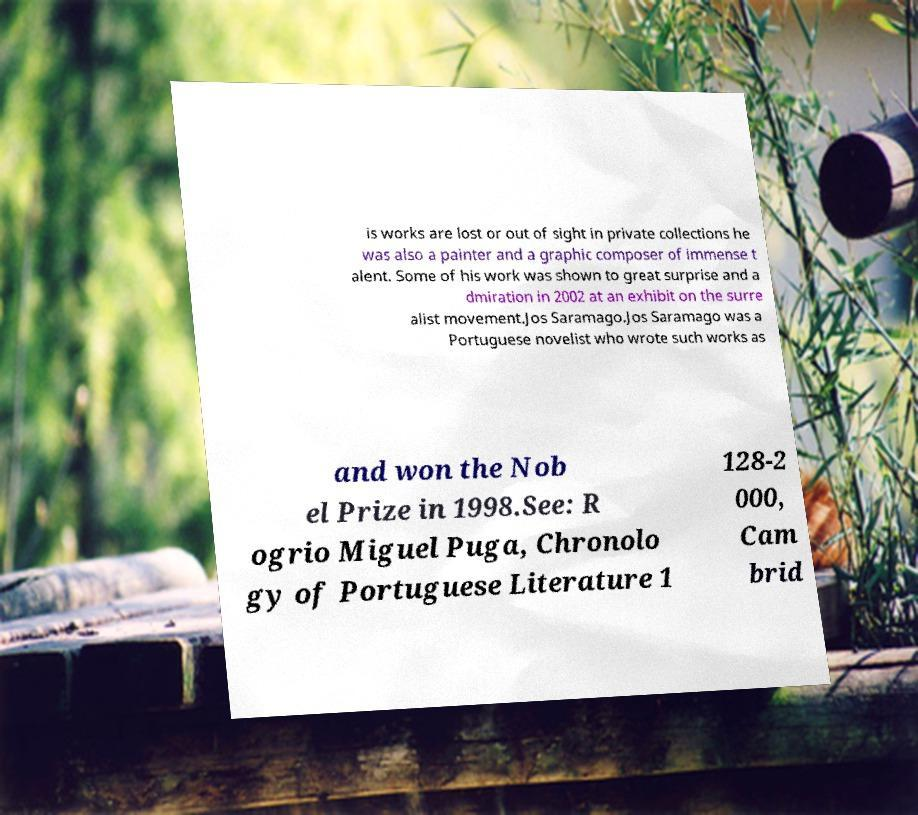Could you assist in decoding the text presented in this image and type it out clearly? is works are lost or out of sight in private collections he was also a painter and a graphic composer of immense t alent. Some of his work was shown to great surprise and a dmiration in 2002 at an exhibit on the surre alist movement.Jos Saramago.Jos Saramago was a Portuguese novelist who wrote such works as and won the Nob el Prize in 1998.See: R ogrio Miguel Puga, Chronolo gy of Portuguese Literature 1 128-2 000, Cam brid 